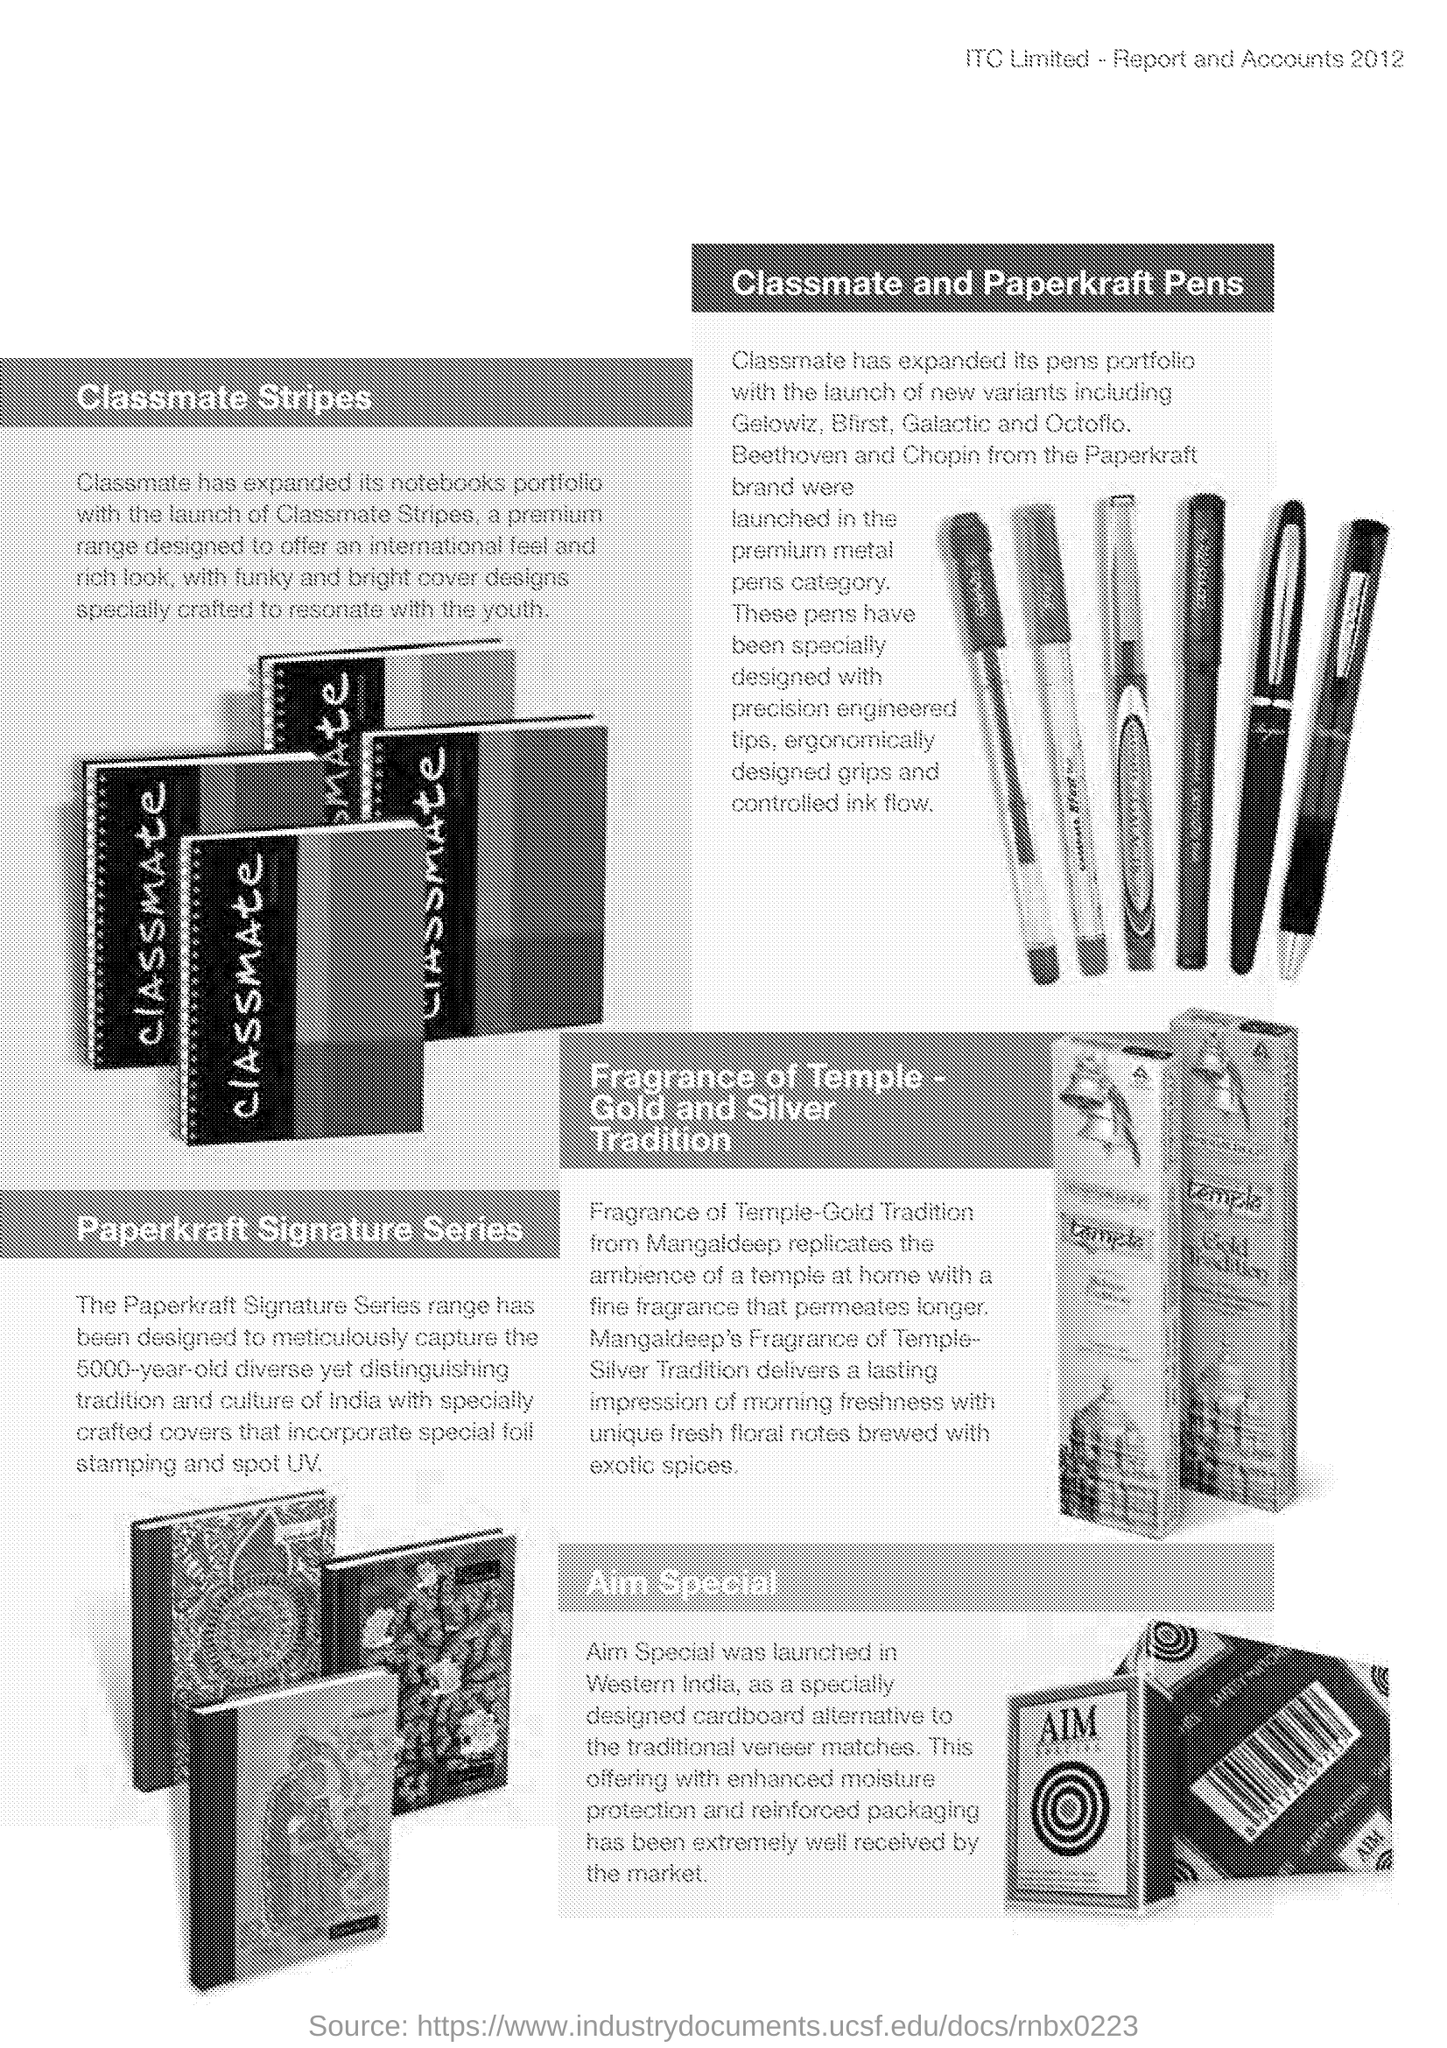What is written on notebooks
Your answer should be compact. Classmate. Where was Aim Special launched
Give a very brief answer. Western India. 